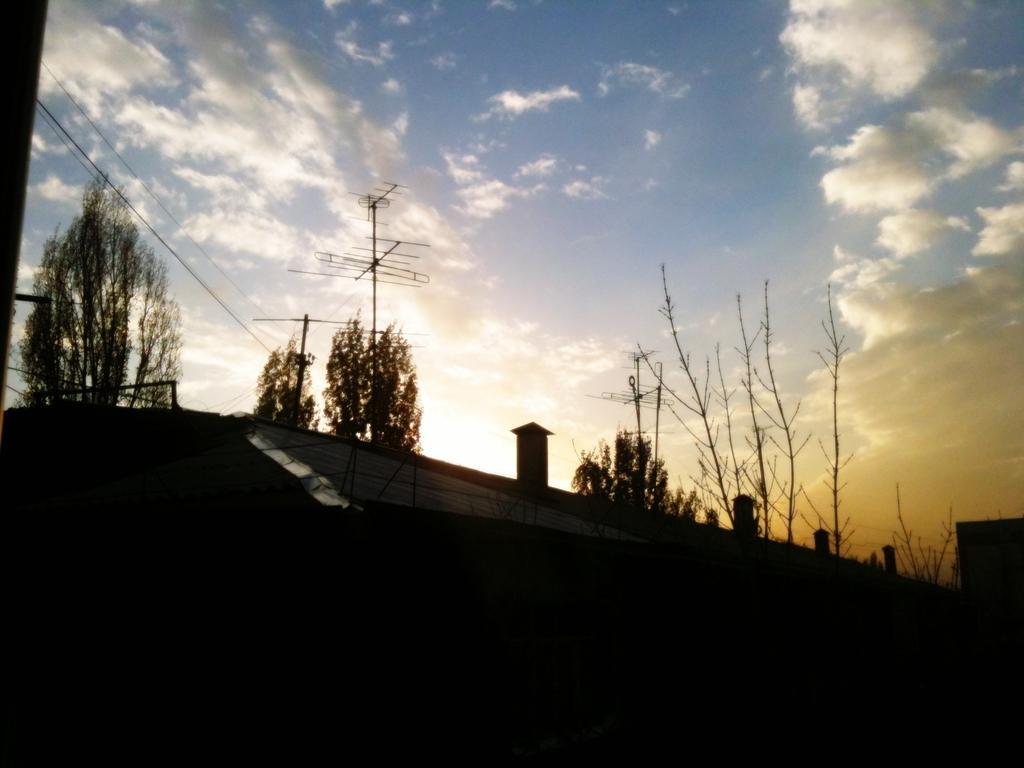Can you describe this image briefly? In this picture we can see a few trees. There are antennas and wires on top. We can see the sky is blue in color and cloudy. There is a dark view at the bottom. 